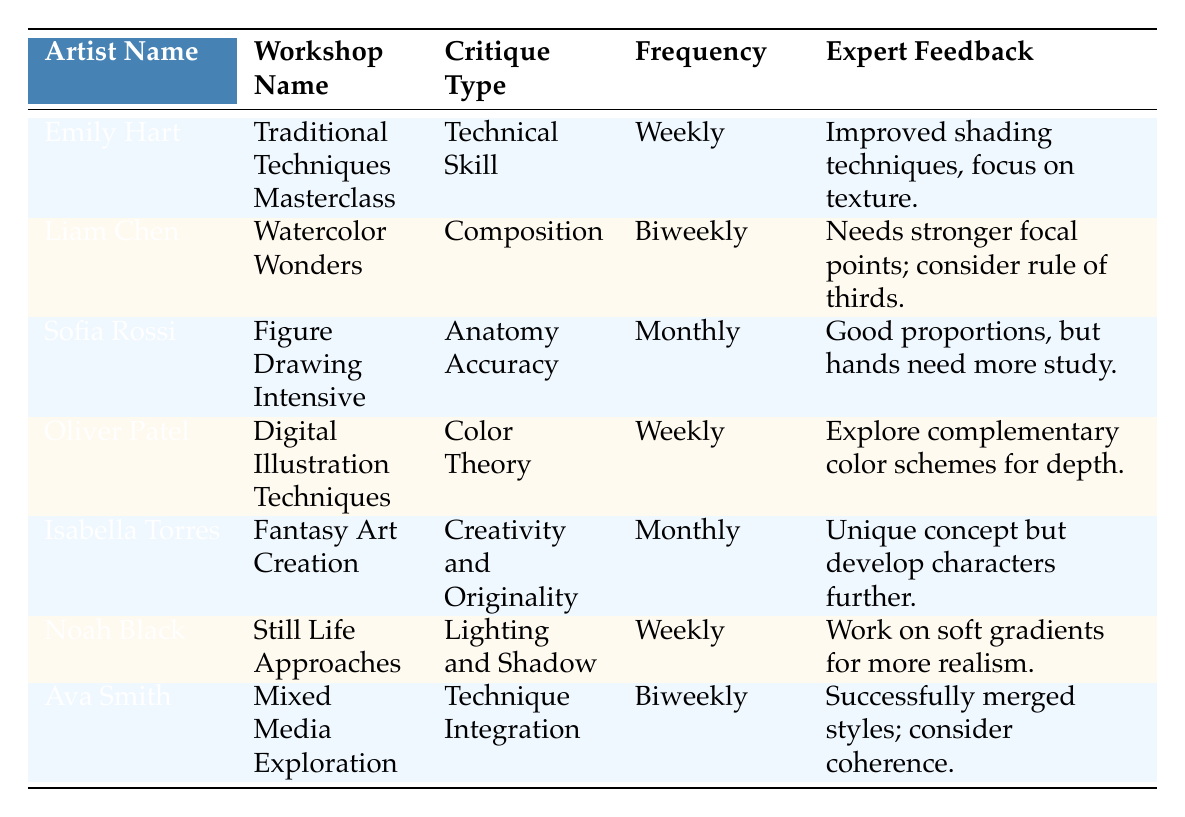What type of critique does Emily Hart receive in her workshop? According to the table, Emily Hart receives critiques related to "Technical Skill" in her workshop.
Answer: Technical Skill How often does Liam Chen receive critique? The table indicates that Liam Chen receives critique on a "Biweekly" basis.
Answer: Biweekly Which artist is critiqued for their "Color Theory"? The table shows that Oliver Patel is critiqued for "Color Theory" in the Digital Illustration Techniques workshop.
Answer: Oliver Patel How many artists receive critiques on a weekly basis? By examining the frequency column, three artists (Emily Hart, Oliver Patel, and Noah Black) receive critiques weekly.
Answer: Three Is the expert feedback for Isabella Torres focused on technique or originality? The feedback for Isabella Torres specifically addresses "Creativity and Originality," indicating that it is focused on originality.
Answer: Originality What is the average frequency of critiques among all artists in the table? The frequencies are weekly (4), biweekly (2), and monthly (2). To calculate the average, consider converting the frequencies to a numerical scale: weekly = 1, biweekly = 2, monthly = 3. The sum is (4*1 + 2*2 + 2*3) = 4 + 4 + 6 = 14. There are 7 artists, so the average is 14/7 = 2.
Answer: 2 Does Noah Black receive feedback on composition? Referring to the table, Noah Black receives feedback on "Lighting and Shadow," so he does not receive feedback on composition.
Answer: No Which artist’s critique involves character development? The table states that Isabella Torres's feedback mentions developing characters further, indicating her critique involves character development.
Answer: Isabella Torres What is the expert feedback provided to Sofia Rossi? The expert feedback for Sofia Rossi is "Good proportions, but hands need more study."
Answer: Good proportions, but hands need more study 